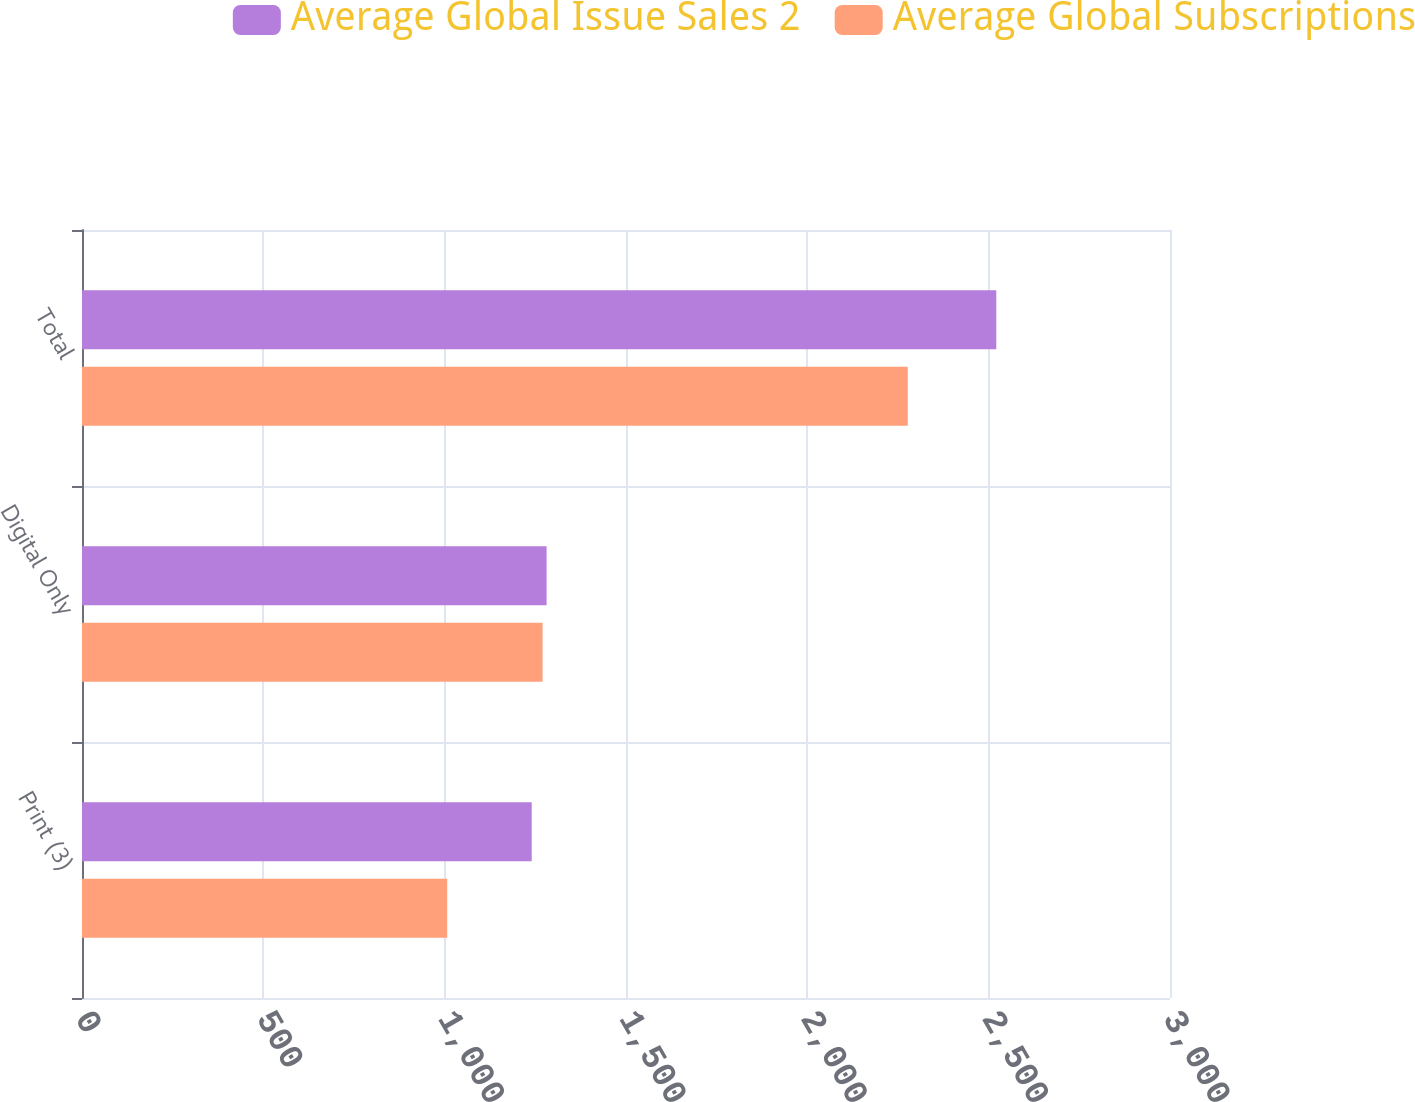Convert chart to OTSL. <chart><loc_0><loc_0><loc_500><loc_500><stacked_bar_chart><ecel><fcel>Print (3)<fcel>Digital Only<fcel>Total<nl><fcel>Average Global Issue Sales 2<fcel>1240<fcel>1281<fcel>2521<nl><fcel>Average Global Subscriptions<fcel>1007<fcel>1270<fcel>2277<nl></chart> 